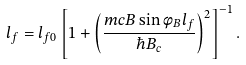<formula> <loc_0><loc_0><loc_500><loc_500>l _ { f } = l _ { f 0 } \left [ 1 + \left ( { \frac { m c B \sin \phi _ { B } l _ { f } } { \hbar { B } _ { c } } } \right ) ^ { 2 } \right ] ^ { - 1 } .</formula> 